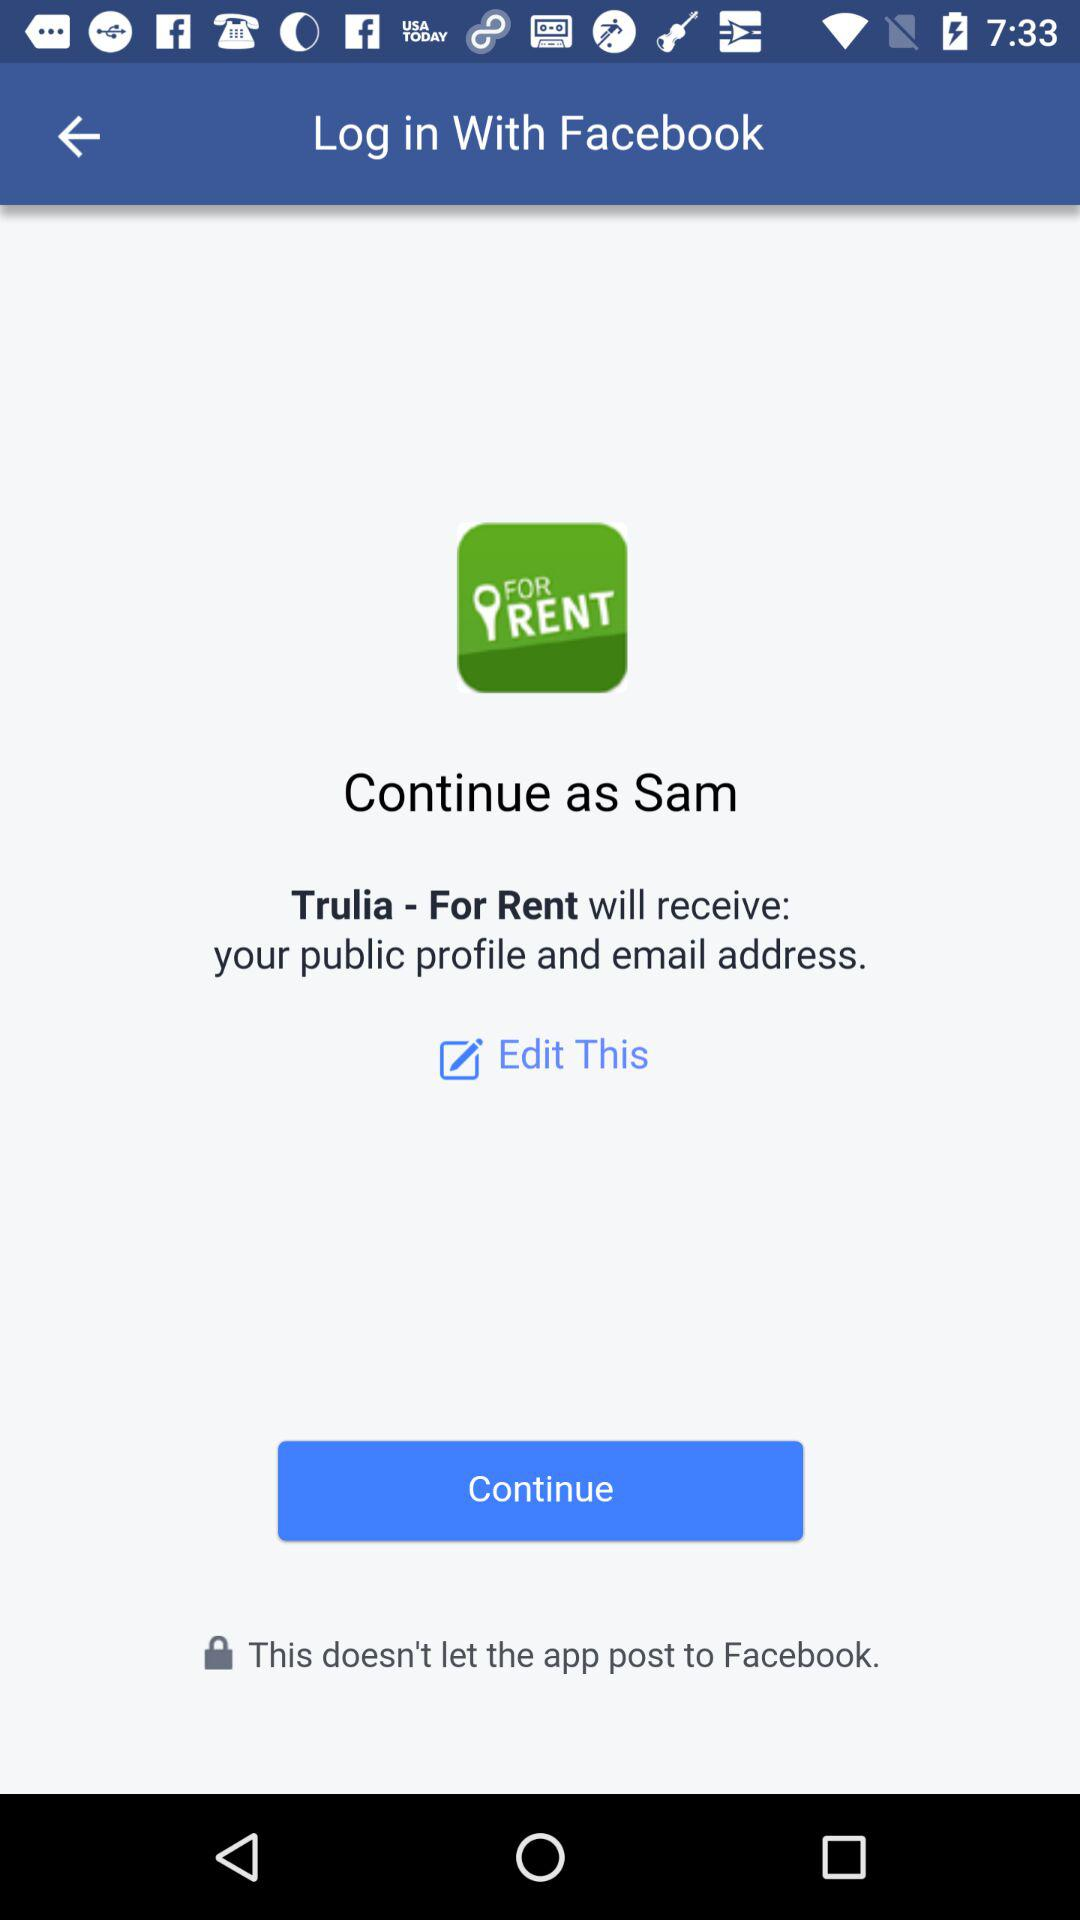Which information will "Trulia - For Rent" receive? "Trulia - For Rent" will receive the public profile and email address. 